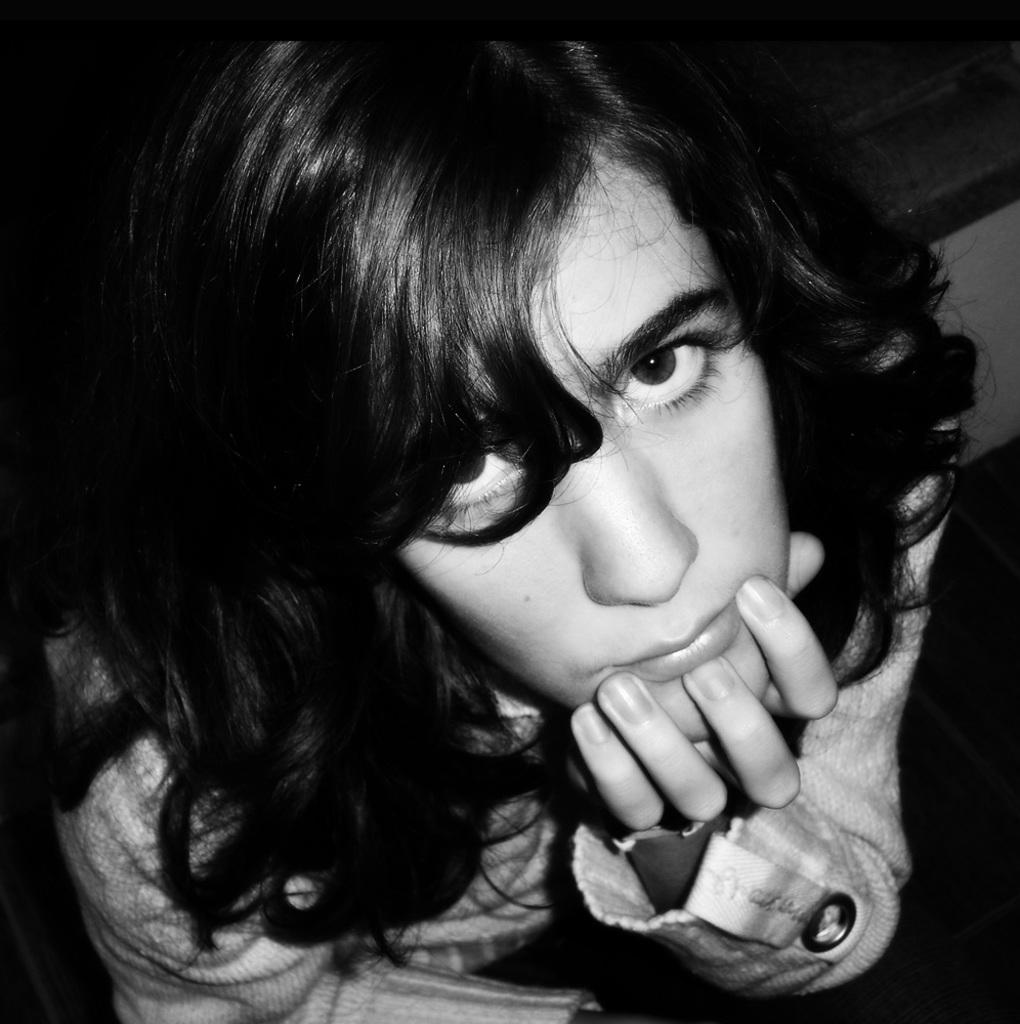What is the color scheme of the image? The image is black and white. What subject is depicted in the image? The image depicts a girl's face. What type of celery is the girl holding in the image? There is no celery present in the image; it only depicts the girl's face. What religious symbol can be seen in the image? There is no religious symbol present in the image; it only depicts the girl's face. 